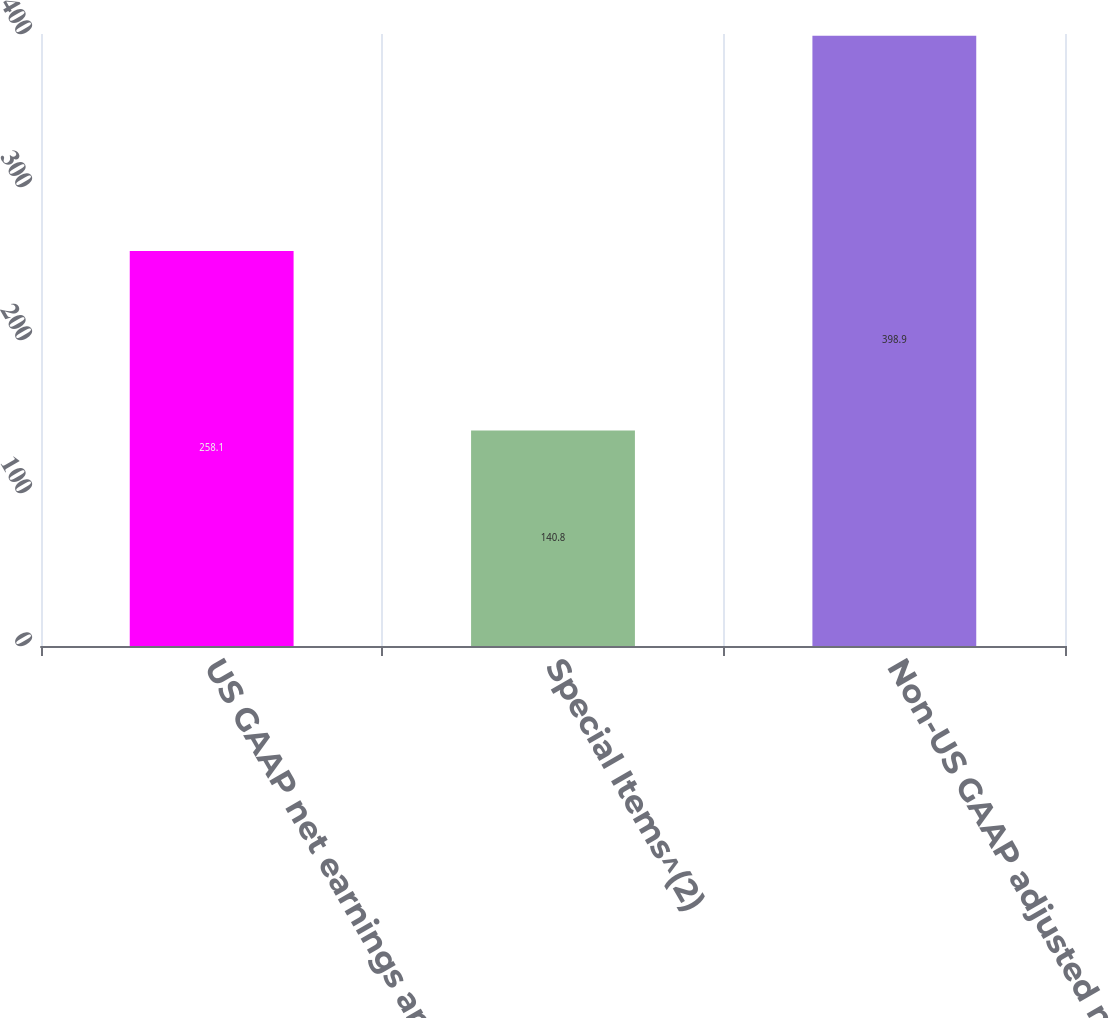Convert chart to OTSL. <chart><loc_0><loc_0><loc_500><loc_500><bar_chart><fcel>US GAAP net earnings and<fcel>Special Items^(2)<fcel>Non-US GAAP adjusted net<nl><fcel>258.1<fcel>140.8<fcel>398.9<nl></chart> 